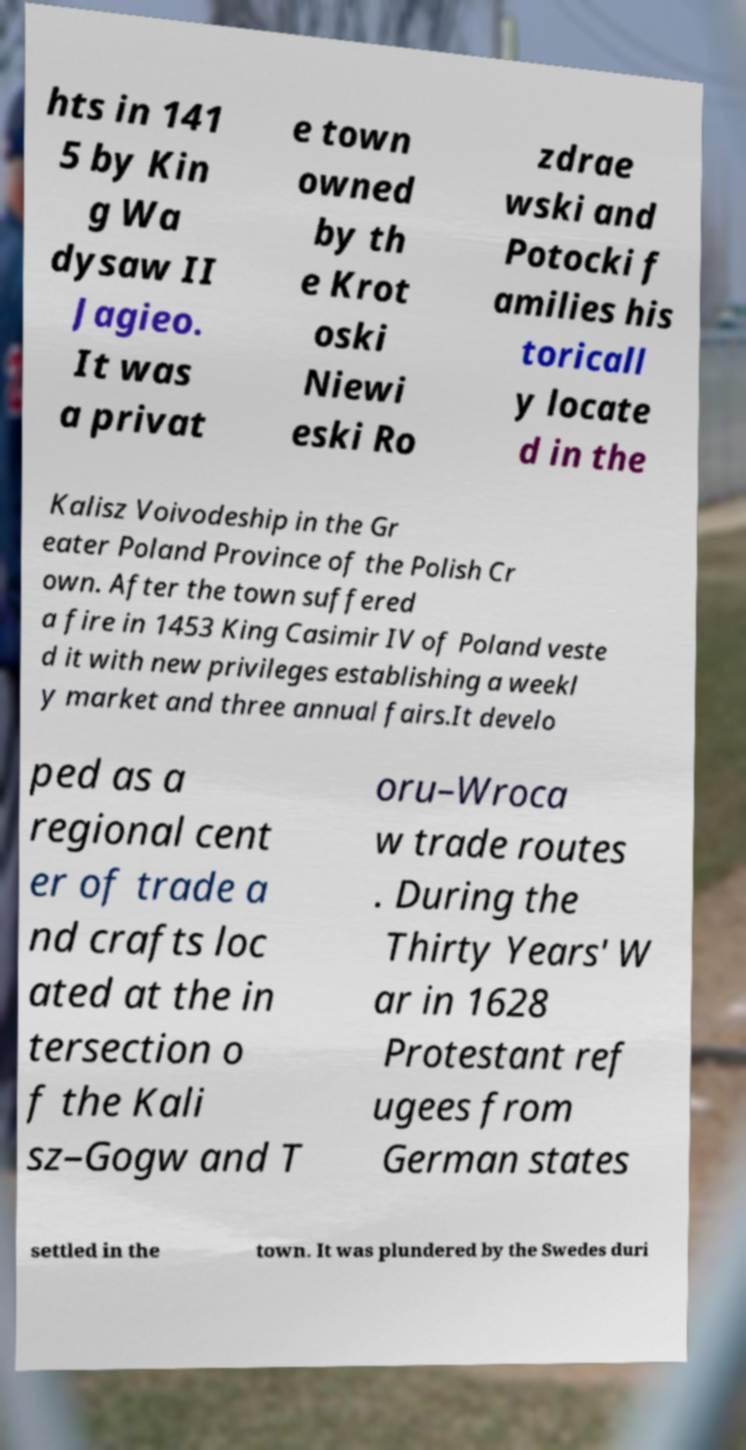I need the written content from this picture converted into text. Can you do that? hts in 141 5 by Kin g Wa dysaw II Jagieo. It was a privat e town owned by th e Krot oski Niewi eski Ro zdrae wski and Potocki f amilies his toricall y locate d in the Kalisz Voivodeship in the Gr eater Poland Province of the Polish Cr own. After the town suffered a fire in 1453 King Casimir IV of Poland veste d it with new privileges establishing a weekl y market and three annual fairs.It develo ped as a regional cent er of trade a nd crafts loc ated at the in tersection o f the Kali sz–Gogw and T oru–Wroca w trade routes . During the Thirty Years' W ar in 1628 Protestant ref ugees from German states settled in the town. It was plundered by the Swedes duri 